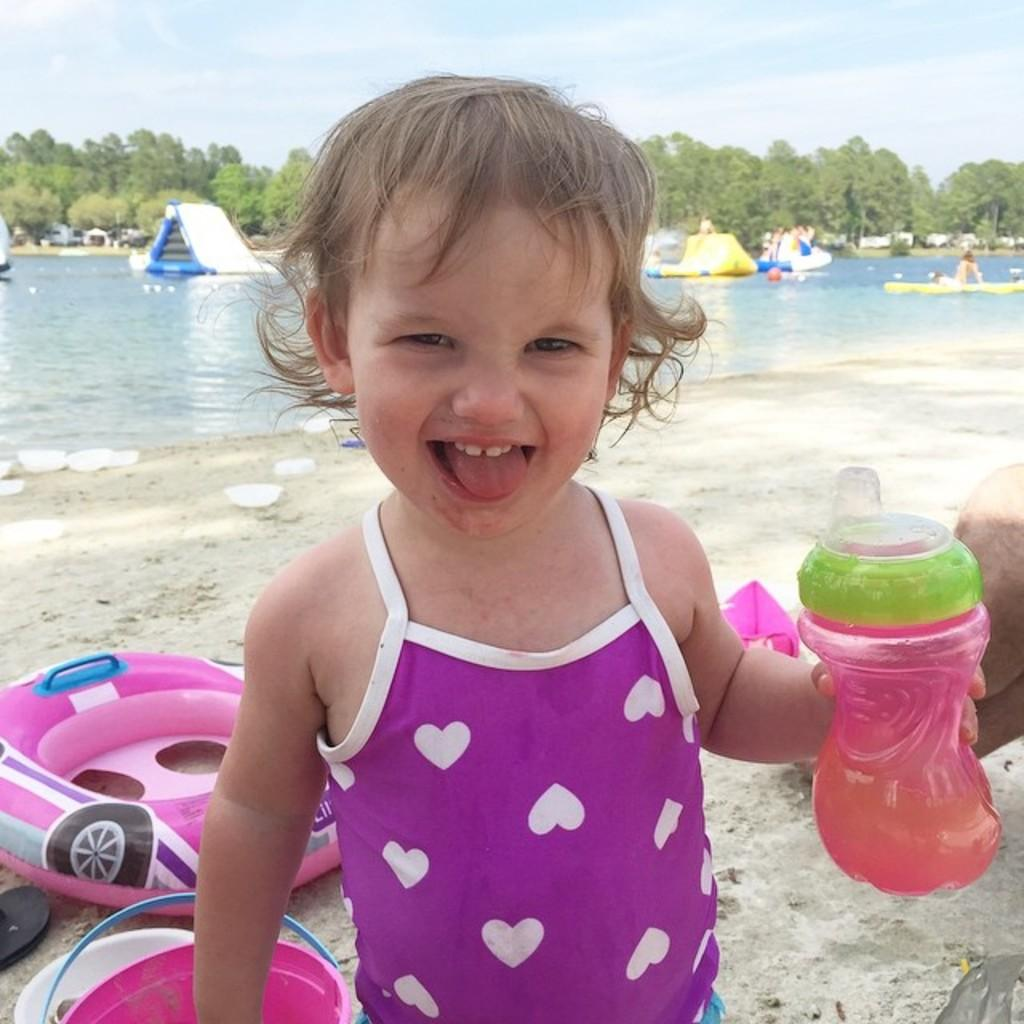What is the child in the image holding? The child is holding a bottle in the image. What else can be seen in the image besides the child? There is a bucket visible in the image. What type of environment is depicted in the background of the image? The background of the image includes sand, water, trees, and the sky. How many geese are flying in the image? There are no geese visible in the image. What type of sail is being used by the child in the image? There is no sail present in the image; the child is holding a bottle and standing in a sandy environment. 